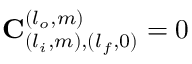Convert formula to latex. <formula><loc_0><loc_0><loc_500><loc_500>C _ { ( l _ { i } , m ) , ( l _ { f } , 0 ) } ^ { ( l _ { o } , m ) } = 0</formula> 